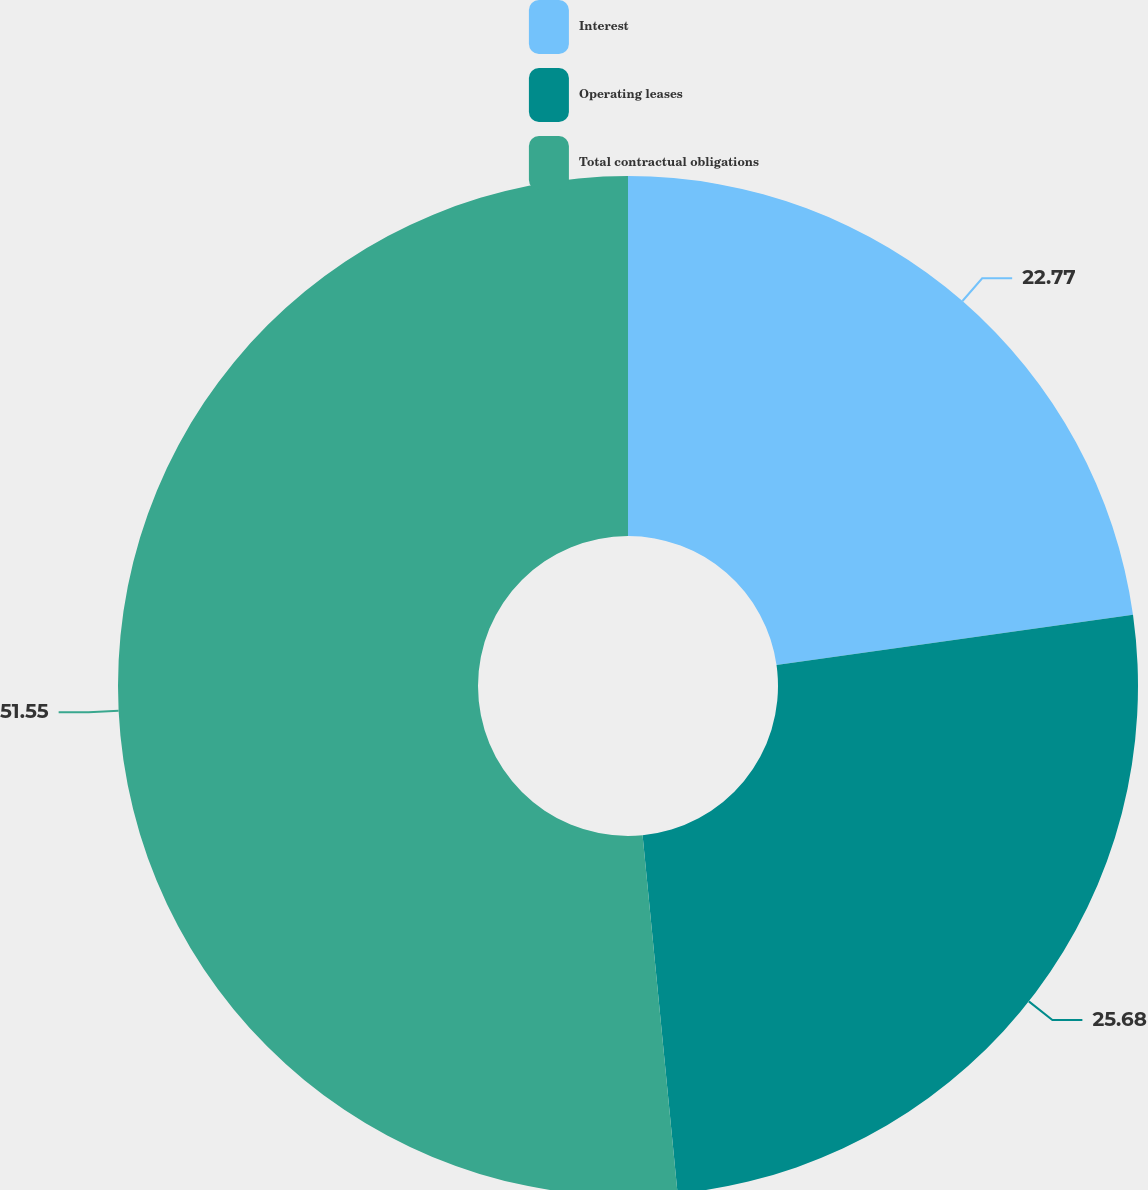Convert chart to OTSL. <chart><loc_0><loc_0><loc_500><loc_500><pie_chart><fcel>Interest<fcel>Operating leases<fcel>Total contractual obligations<nl><fcel>22.77%<fcel>25.68%<fcel>51.55%<nl></chart> 